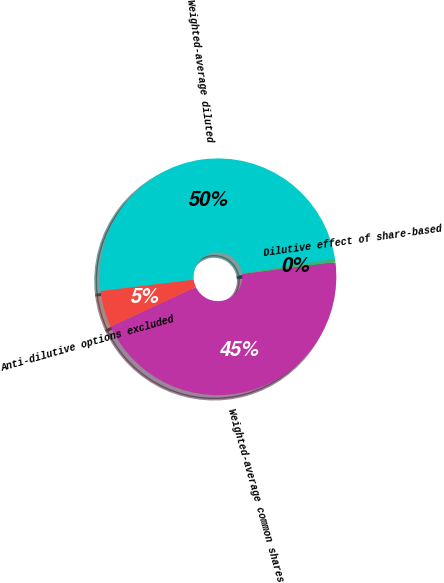Convert chart. <chart><loc_0><loc_0><loc_500><loc_500><pie_chart><fcel>Weighted-average common shares<fcel>Dilutive effect of share-based<fcel>Weighted-average diluted<fcel>Anti-dilutive options excluded<nl><fcel>45.01%<fcel>0.49%<fcel>49.51%<fcel>4.99%<nl></chart> 